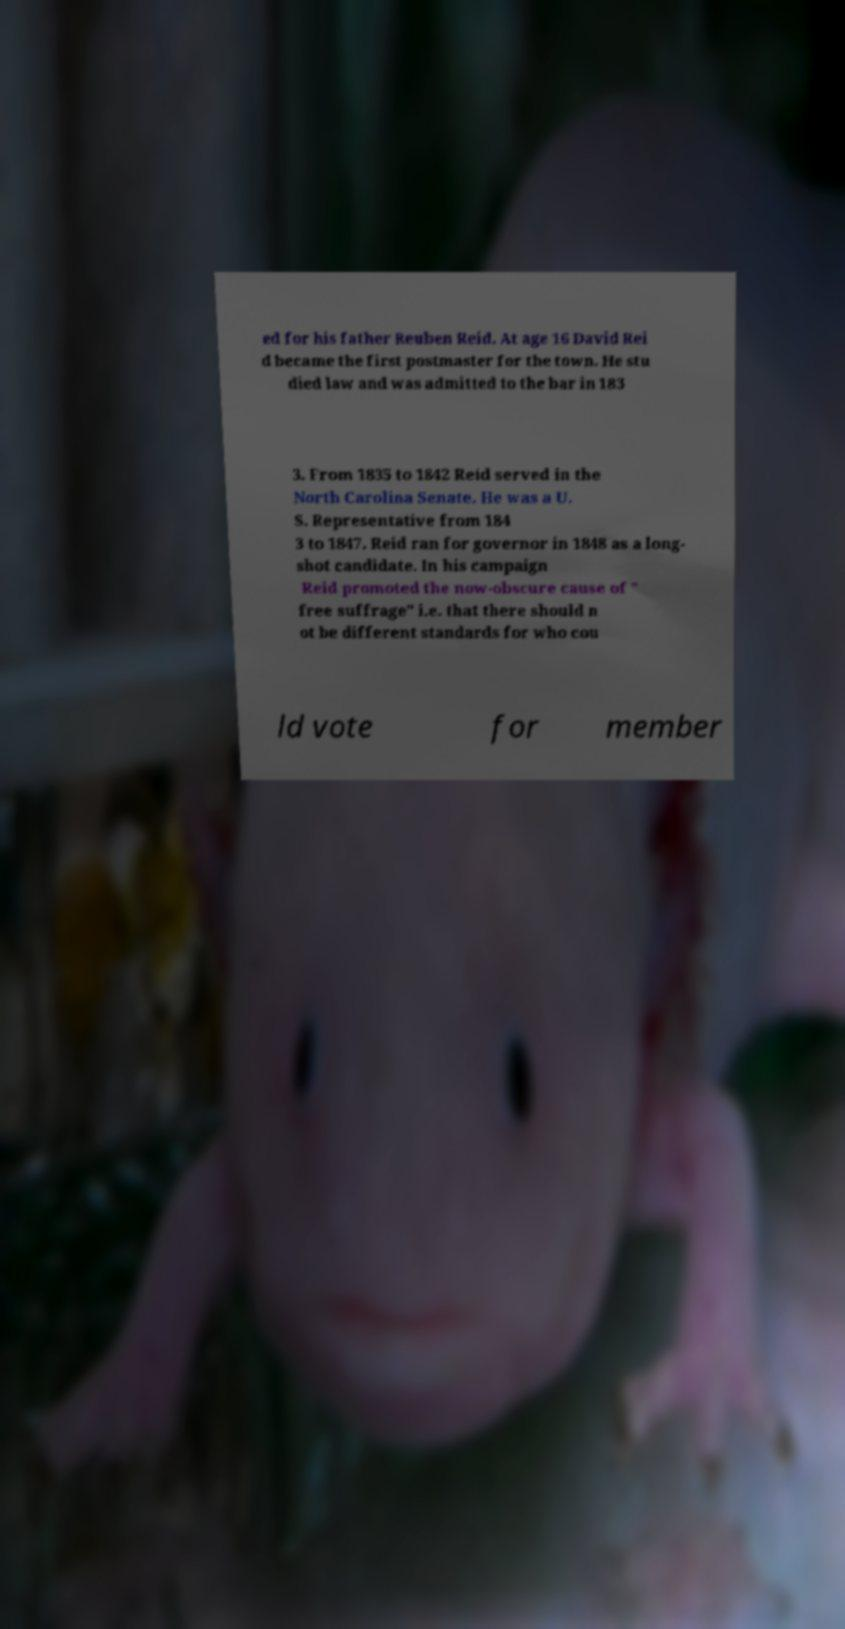Can you read and provide the text displayed in the image?This photo seems to have some interesting text. Can you extract and type it out for me? ed for his father Reuben Reid. At age 16 David Rei d became the first postmaster for the town. He stu died law and was admitted to the bar in 183 3. From 1835 to 1842 Reid served in the North Carolina Senate. He was a U. S. Representative from 184 3 to 1847. Reid ran for governor in 1848 as a long- shot candidate. In his campaign Reid promoted the now-obscure cause of " free suffrage" i.e. that there should n ot be different standards for who cou ld vote for member 